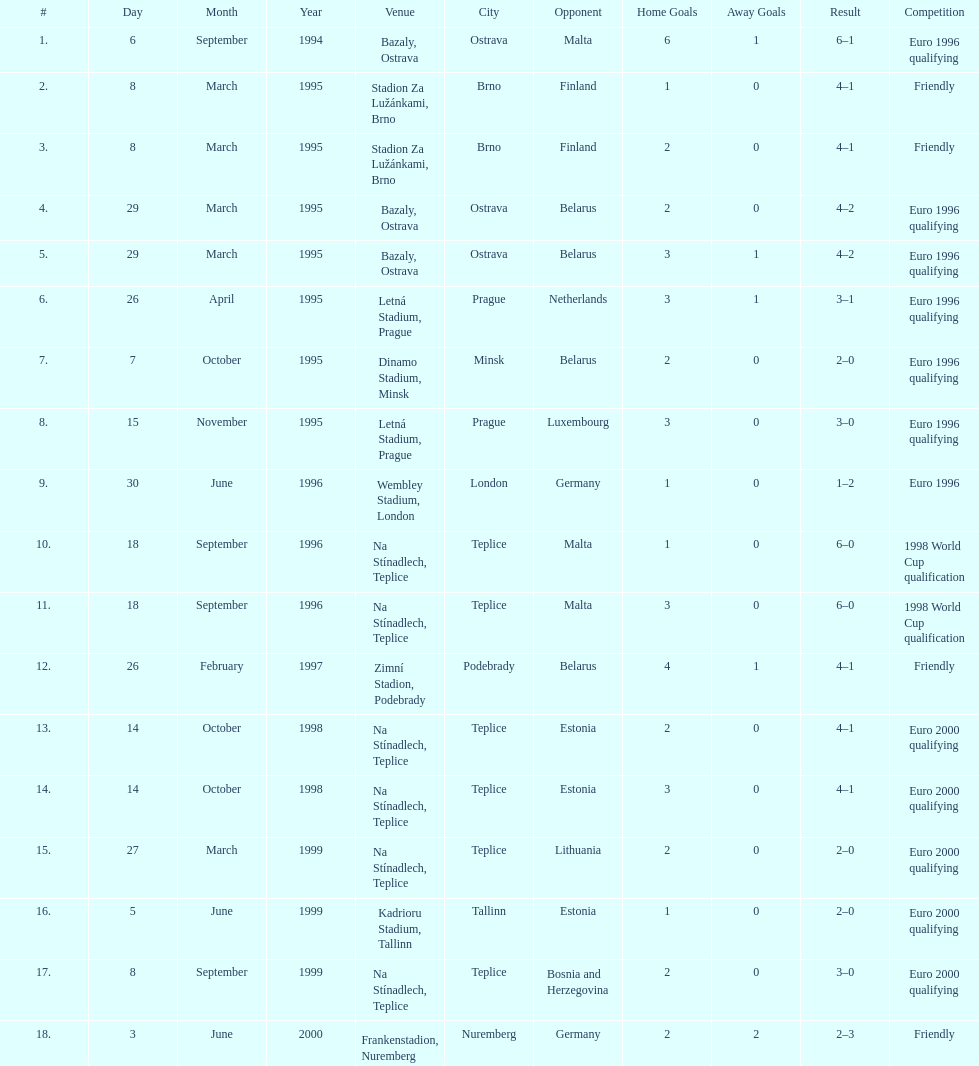How many total games took place in 1999? 3. 